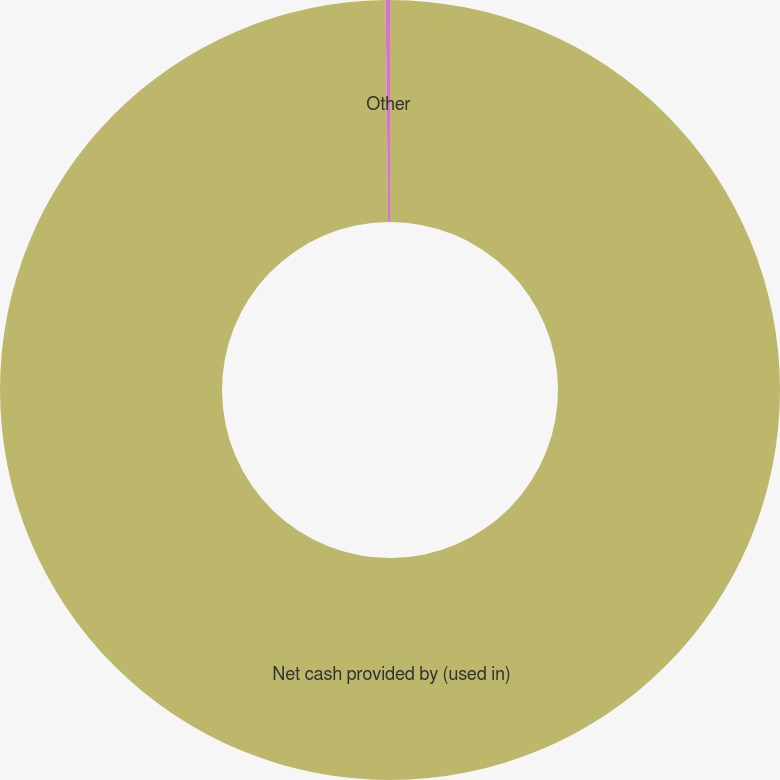Convert chart. <chart><loc_0><loc_0><loc_500><loc_500><pie_chart><fcel>Net cash provided by (used in)<fcel>Other<nl><fcel>99.82%<fcel>0.18%<nl></chart> 